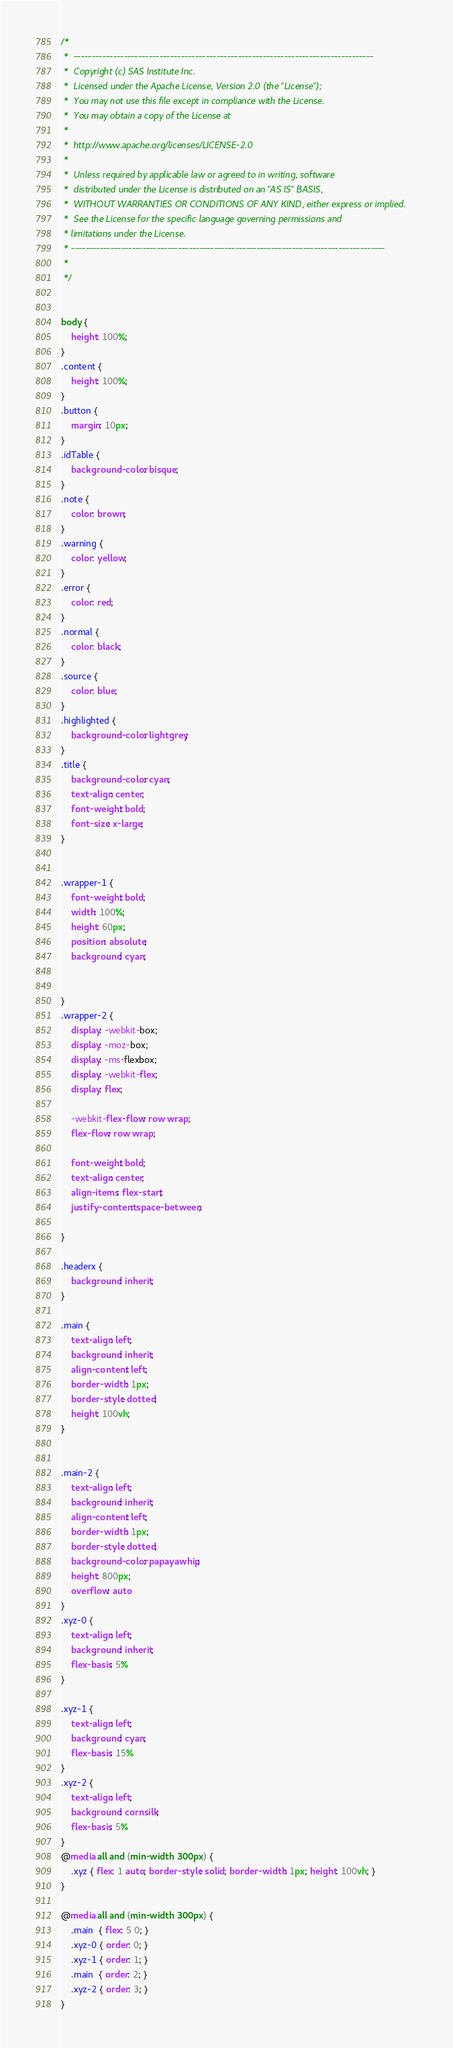Convert code to text. <code><loc_0><loc_0><loc_500><loc_500><_CSS_>/*
 *  ------------------------------------------------------------------------------------
 *  Copyright (c) SAS Institute Inc.
 *  Licensed under the Apache License, Version 2.0 (the "License");
 *  You may not use this file except in compliance with the License.
 *  You may obtain a copy of the License at
 *
 *  http://www.apache.org/licenses/LICENSE-2.0
 *
 *  Unless required by applicable law or agreed to in writing, software
 *  distributed under the License is distributed on an "AS IS" BASIS,
 *  WITHOUT WARRANTIES OR CONDITIONS OF ANY KIND, either express or implied.
 *  See the License for the specific language governing permissions and
 * limitations under the License.
 * ----------------------------------------------------------------------------------------
 *
 */


body {
    height: 100%;
}
.content {
    height: 100%;
}
.button {
    margin: 10px;
}
.idTable {
    background-color: bisque;
}
.note {
    color: brown;
}
.warning {
    color: yellow;
}
.error {
    color: red;
}
.normal {
    color: black;
}
.source {
    color: blue;
}
.highlighted {
    background-color: lightgrey;
}
.title {
    background-color: cyan;
    text-align: center;
    font-weight: bold;
    font-size: x-large;
}


.wrapper-1 {
    font-weight: bold;
    width: 100%;
    height: 60px;
    position: absolute;
    background: cyan;


}
.wrapper-2 {
    display: -webkit-box;
    display: -moz-box;
    display: -ms-flexbox;
    display: -webkit-flex;
    display: flex;

    -webkit-flex-flow: row wrap;
    flex-flow: row wrap;

    font-weight: bold;
    text-align: center;
    align-items: flex-start;
    justify-content: space-between;

}

.headerx {
    background: inherit;
}

.main {
    text-align: left;
    background: inherit;
    align-content: left;
    border-width: 1px;
    border-style: dotted;
    height: 100vh;
}


.main-2 {
    text-align: left;
    background: inherit;
    align-content: left;
    border-width: 1px;
    border-style: dotted;
    background-color: papayawhip;
    height: 800px;
    overflow: auto
}
.xyz-0 {
    text-align: left;
    background: inherit;
    flex-basis: 5%
}

.xyz-1 {
    text-align: left;
    background: cyan;
    flex-basis: 15%
}
.xyz-2 {
    text-align: left;
    background: cornsilk;
    flex-basis: 5%
}
@media all and (min-width: 300px) {
    .xyz { flex: 1 auto; border-style: solid; border-width: 1px; height: 100vh; }
}

@media all and (min-width: 300px) {
    .main  { flex: 5 0; }
    .xyz-0 { order: 0; }
    .xyz-1 { order: 1; }
    .main  { order: 2; }
    .xyz-2 { order: 3; }
}
</code> 